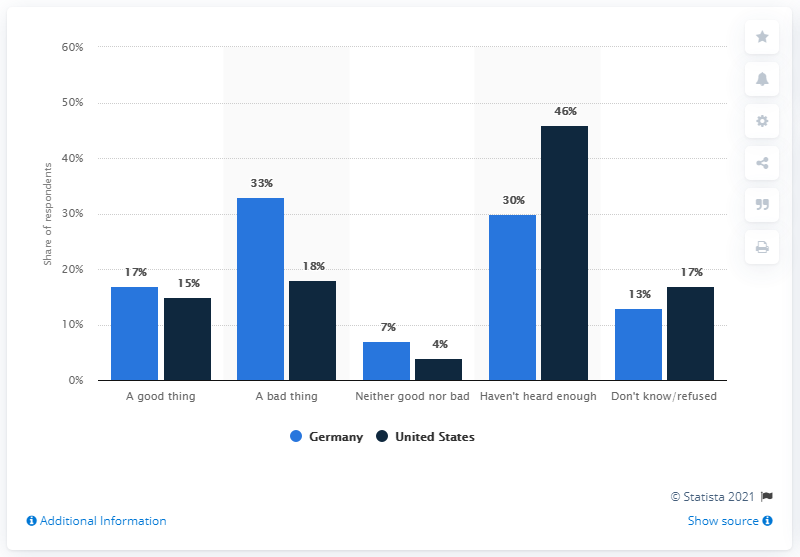Give some essential details in this illustration. According to the survey, 33% of respondents believe that TTIP is detrimental to Germany. Out of the total number of navy blue bars, how many exceed the value of 30%? 